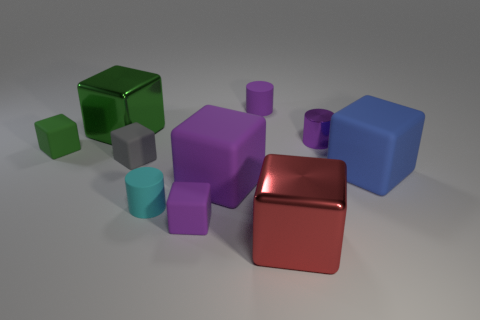Subtract all red blocks. How many blocks are left? 6 Subtract all blue blocks. How many blocks are left? 6 Subtract all blue blocks. Subtract all purple spheres. How many blocks are left? 6 Subtract all cylinders. How many objects are left? 7 Subtract 1 purple cylinders. How many objects are left? 9 Subtract all balls. Subtract all small gray cubes. How many objects are left? 9 Add 5 gray rubber things. How many gray rubber things are left? 6 Add 8 red shiny balls. How many red shiny balls exist? 8 